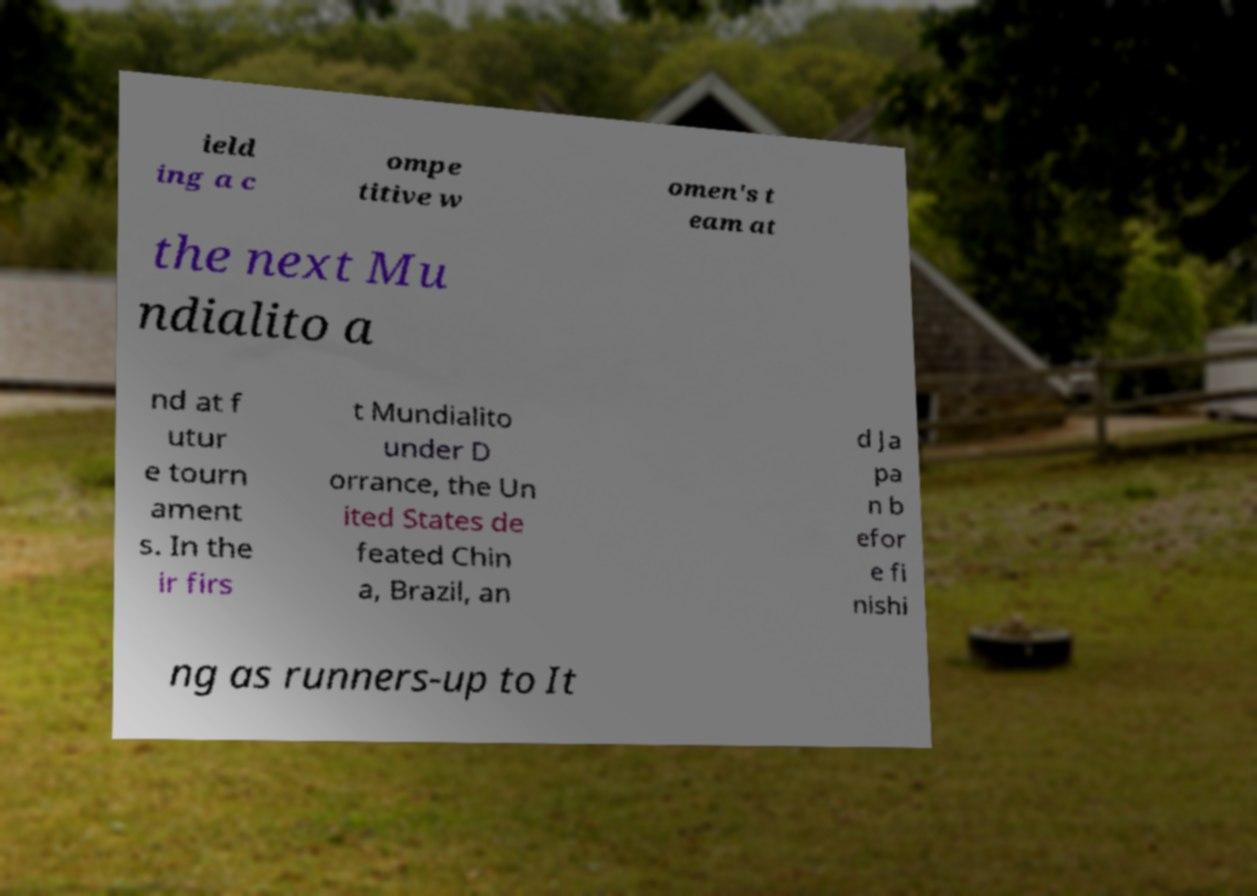Can you read and provide the text displayed in the image?This photo seems to have some interesting text. Can you extract and type it out for me? ield ing a c ompe titive w omen's t eam at the next Mu ndialito a nd at f utur e tourn ament s. In the ir firs t Mundialito under D orrance, the Un ited States de feated Chin a, Brazil, an d Ja pa n b efor e fi nishi ng as runners-up to It 